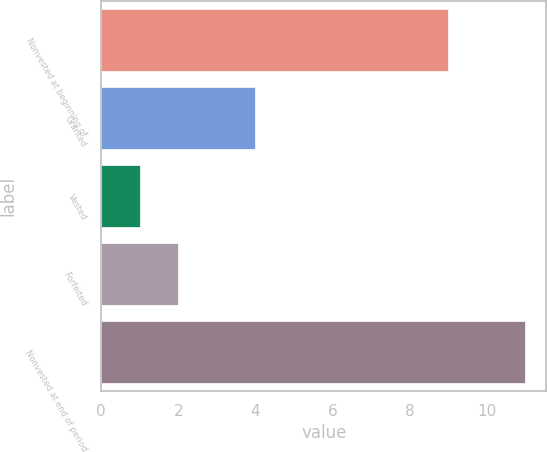<chart> <loc_0><loc_0><loc_500><loc_500><bar_chart><fcel>Nonvested at beginning of<fcel>Granted<fcel>Vested<fcel>Forfeited<fcel>Nonvested at end of period<nl><fcel>9<fcel>4<fcel>1<fcel>2<fcel>11<nl></chart> 